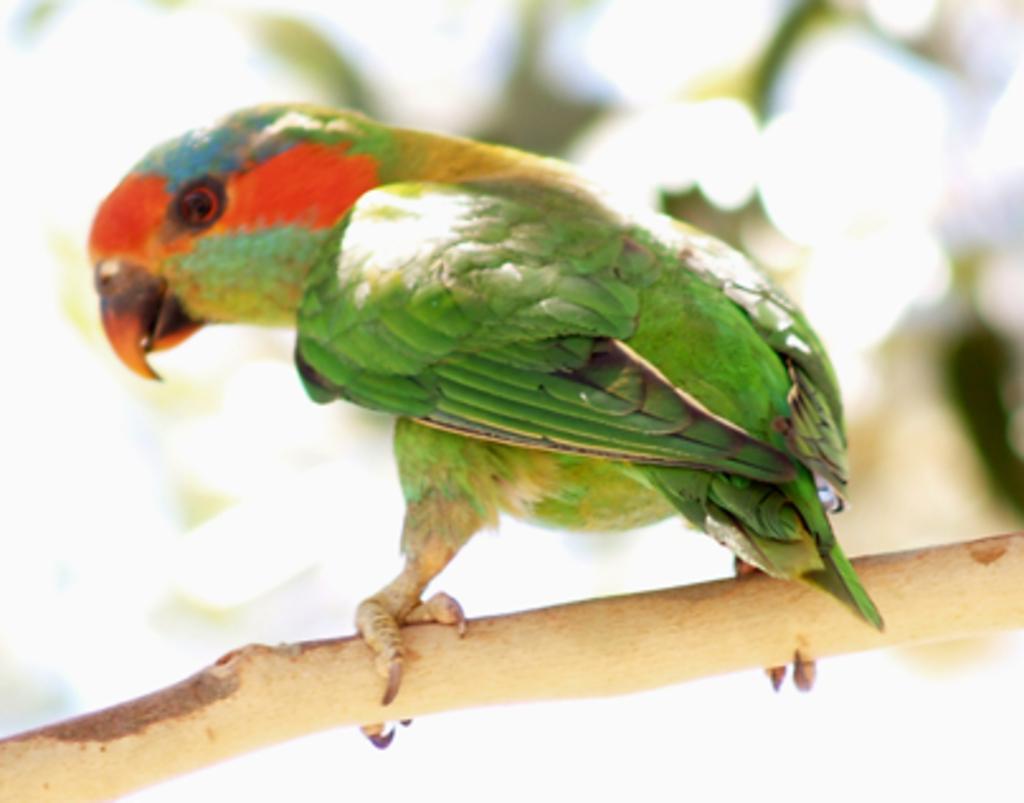Could you give a brief overview of what you see in this image? There is a green color parrot standing on the branch of a tree. And the background is blurred. 